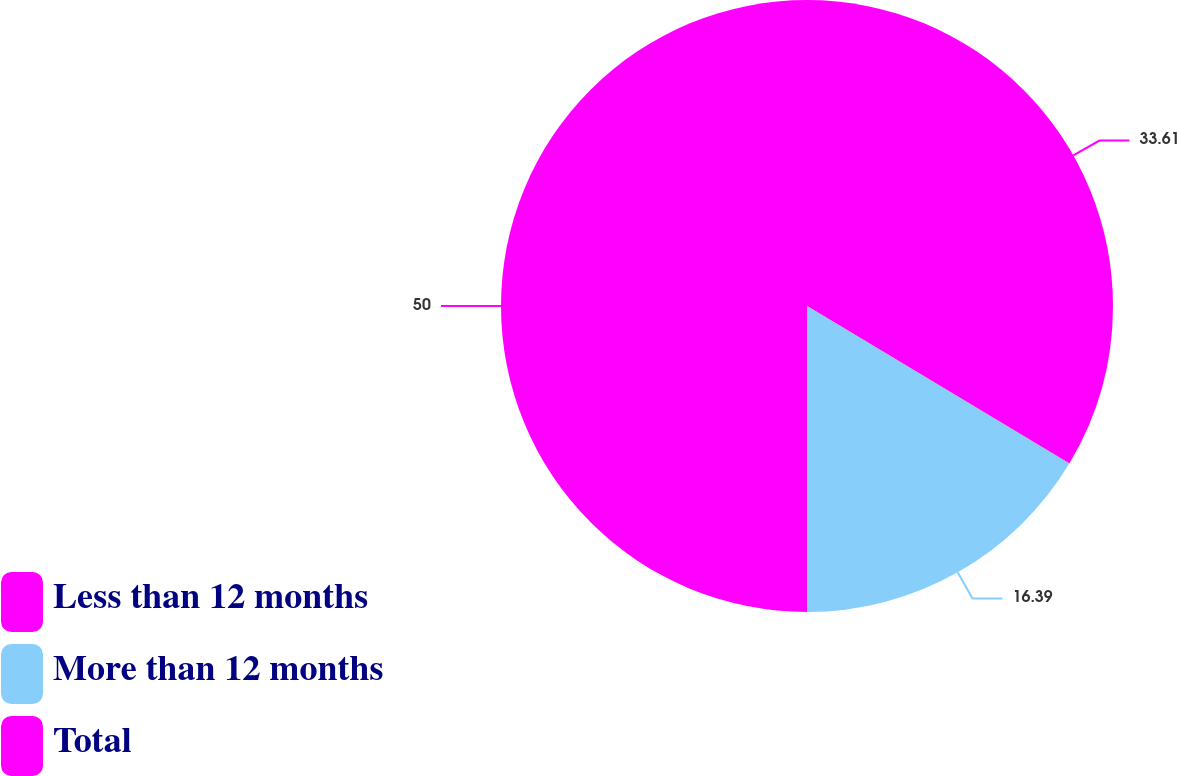Convert chart. <chart><loc_0><loc_0><loc_500><loc_500><pie_chart><fcel>Less than 12 months<fcel>More than 12 months<fcel>Total<nl><fcel>33.61%<fcel>16.39%<fcel>50.0%<nl></chart> 